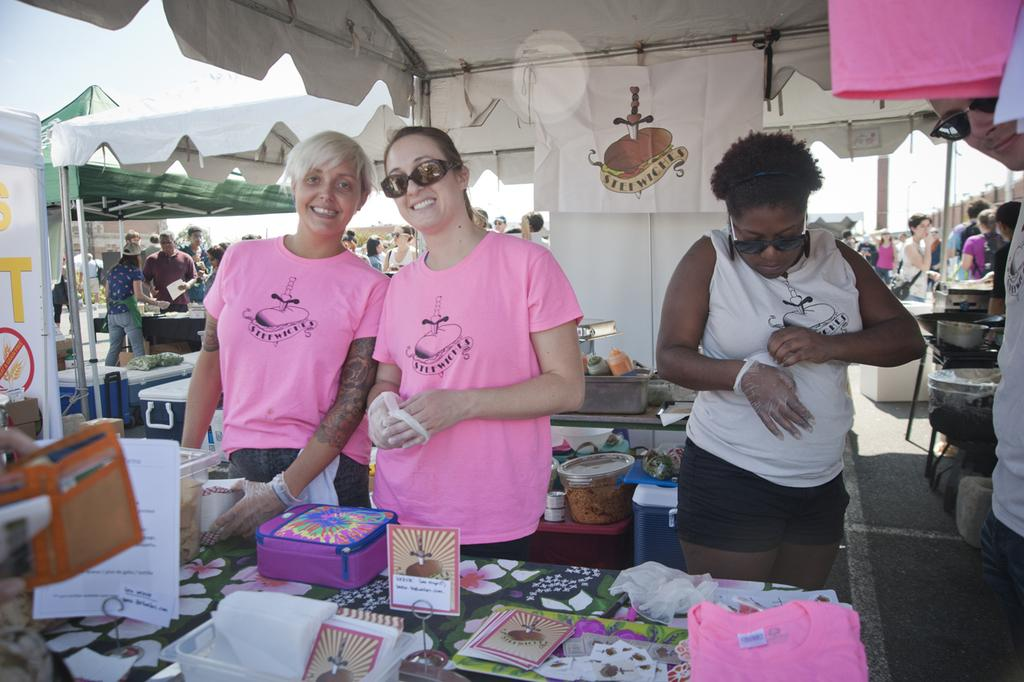What can be seen in the image? There are people standing in the image, and there are stalls present as well. What is visible in the background of the image? The sky is visible in the background of the image. How can you describe the color tint at the top of the image? There is a white color tint at the top of the image. What type of wine is being served at the stalls in the image? There is no wine present in the image; it features people standing near stalls with no mention of wine. Can you see any berries on the stalls in the image? There is no mention of berries in the image; it only describes people standing near stalls. 